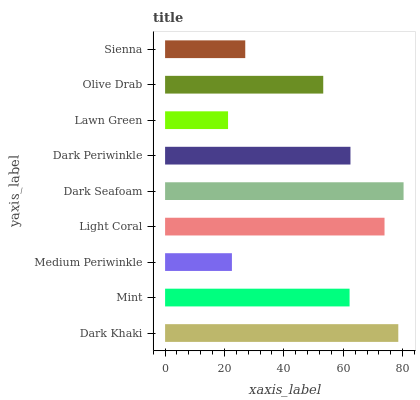Is Lawn Green the minimum?
Answer yes or no. Yes. Is Dark Seafoam the maximum?
Answer yes or no. Yes. Is Mint the minimum?
Answer yes or no. No. Is Mint the maximum?
Answer yes or no. No. Is Dark Khaki greater than Mint?
Answer yes or no. Yes. Is Mint less than Dark Khaki?
Answer yes or no. Yes. Is Mint greater than Dark Khaki?
Answer yes or no. No. Is Dark Khaki less than Mint?
Answer yes or no. No. Is Mint the high median?
Answer yes or no. Yes. Is Mint the low median?
Answer yes or no. Yes. Is Lawn Green the high median?
Answer yes or no. No. Is Olive Drab the low median?
Answer yes or no. No. 